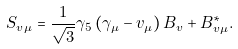<formula> <loc_0><loc_0><loc_500><loc_500>S _ { v \mu } = \frac { 1 } { \sqrt { 3 } } \gamma _ { 5 } \left ( \gamma _ { \mu } - v _ { \mu } \right ) B _ { v } + B _ { v \mu } ^ { * } .</formula> 